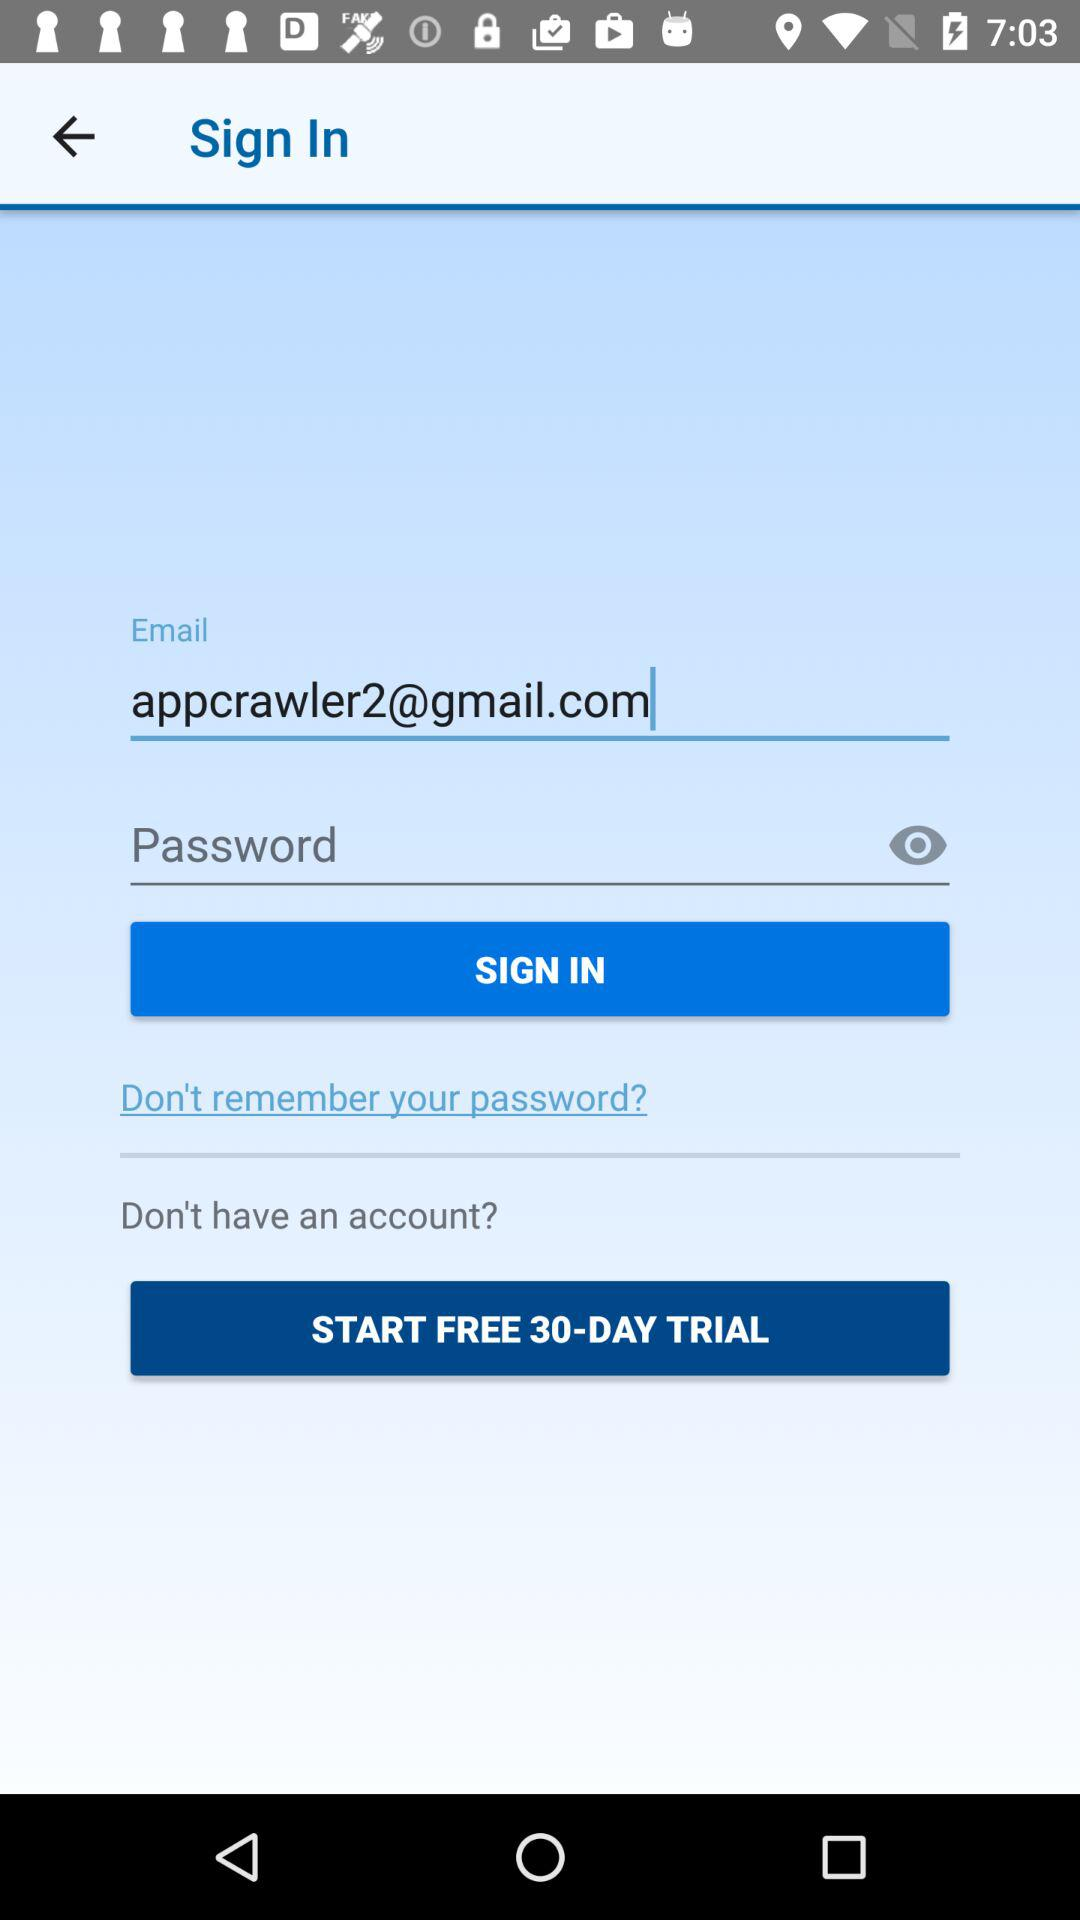What is the email address? The email address is appcrawler2@gmail.com. 